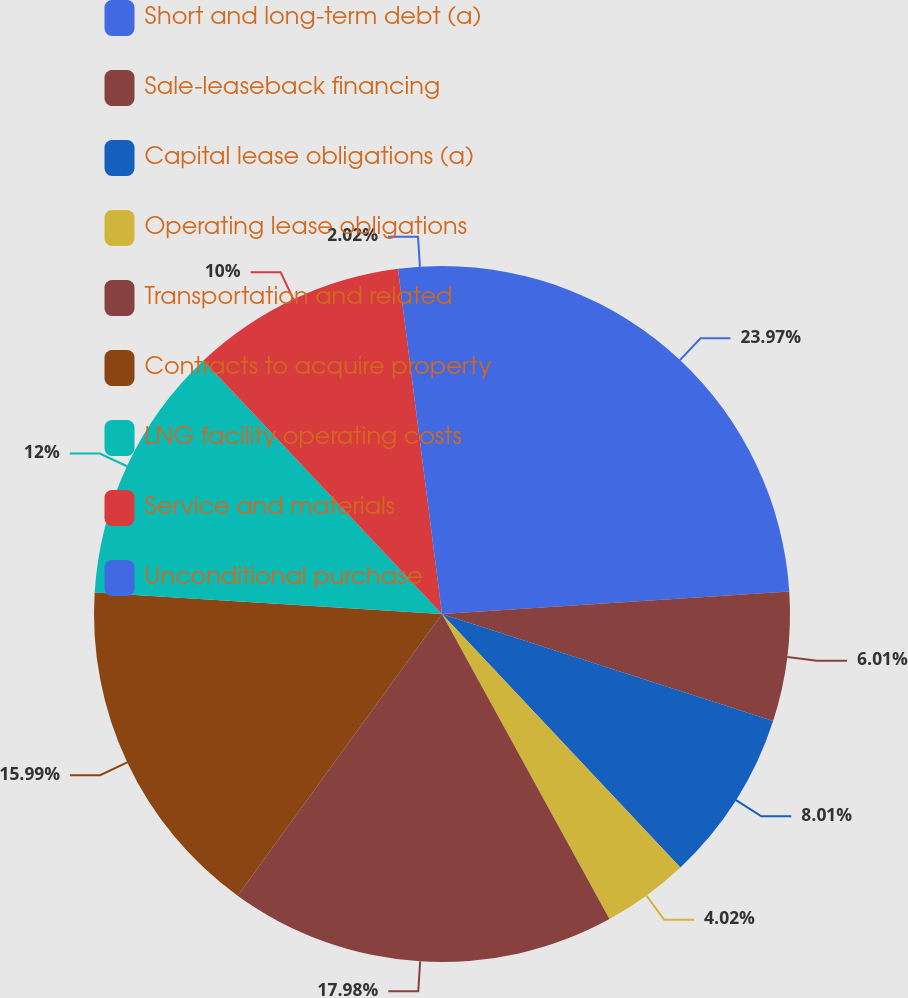Convert chart. <chart><loc_0><loc_0><loc_500><loc_500><pie_chart><fcel>Short and long-term debt (a)<fcel>Sale-leaseback financing<fcel>Capital lease obligations (a)<fcel>Operating lease obligations<fcel>Transportation and related<fcel>Contracts to acquire property<fcel>LNG facility operating costs<fcel>Service and materials<fcel>Unconditional purchase<nl><fcel>23.97%<fcel>6.01%<fcel>8.01%<fcel>4.02%<fcel>17.98%<fcel>15.99%<fcel>12.0%<fcel>10.0%<fcel>2.02%<nl></chart> 